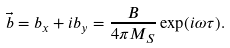<formula> <loc_0><loc_0><loc_500><loc_500>\vec { b } = b _ { x } + { i } b _ { y } = \frac { B } { 4 \pi M _ { S } } \exp ( { i } \omega \tau ) .</formula> 